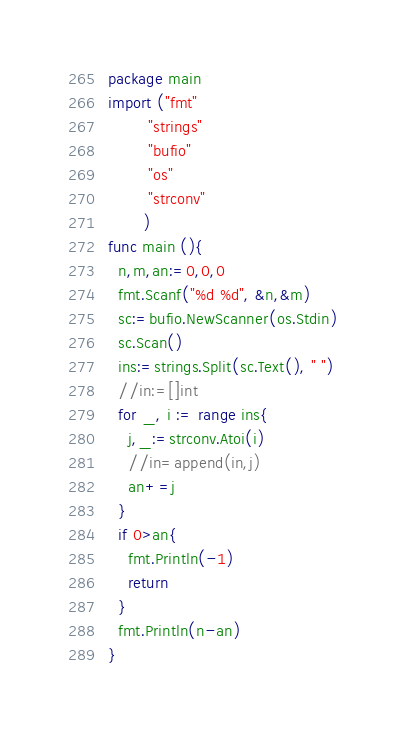<code> <loc_0><loc_0><loc_500><loc_500><_Go_>package main
import ("fmt"
        "strings"
        "bufio"
        "os"
        "strconv"
       )
func main (){
  n,m,an:=0,0,0
  fmt.Scanf("%d %d", &n,&m)
  sc:=bufio.NewScanner(os.Stdin)
  sc.Scan()
  ins:=strings.Split(sc.Text(), " ")
  //in:=[]int
  for _, i := range ins{
    j,_:=strconv.Atoi(i)
    //in=append(in,j)
    an+=j
  }
  if 0>an{
    fmt.Println(-1)
    return
  }
  fmt.Println(n-an)
}</code> 